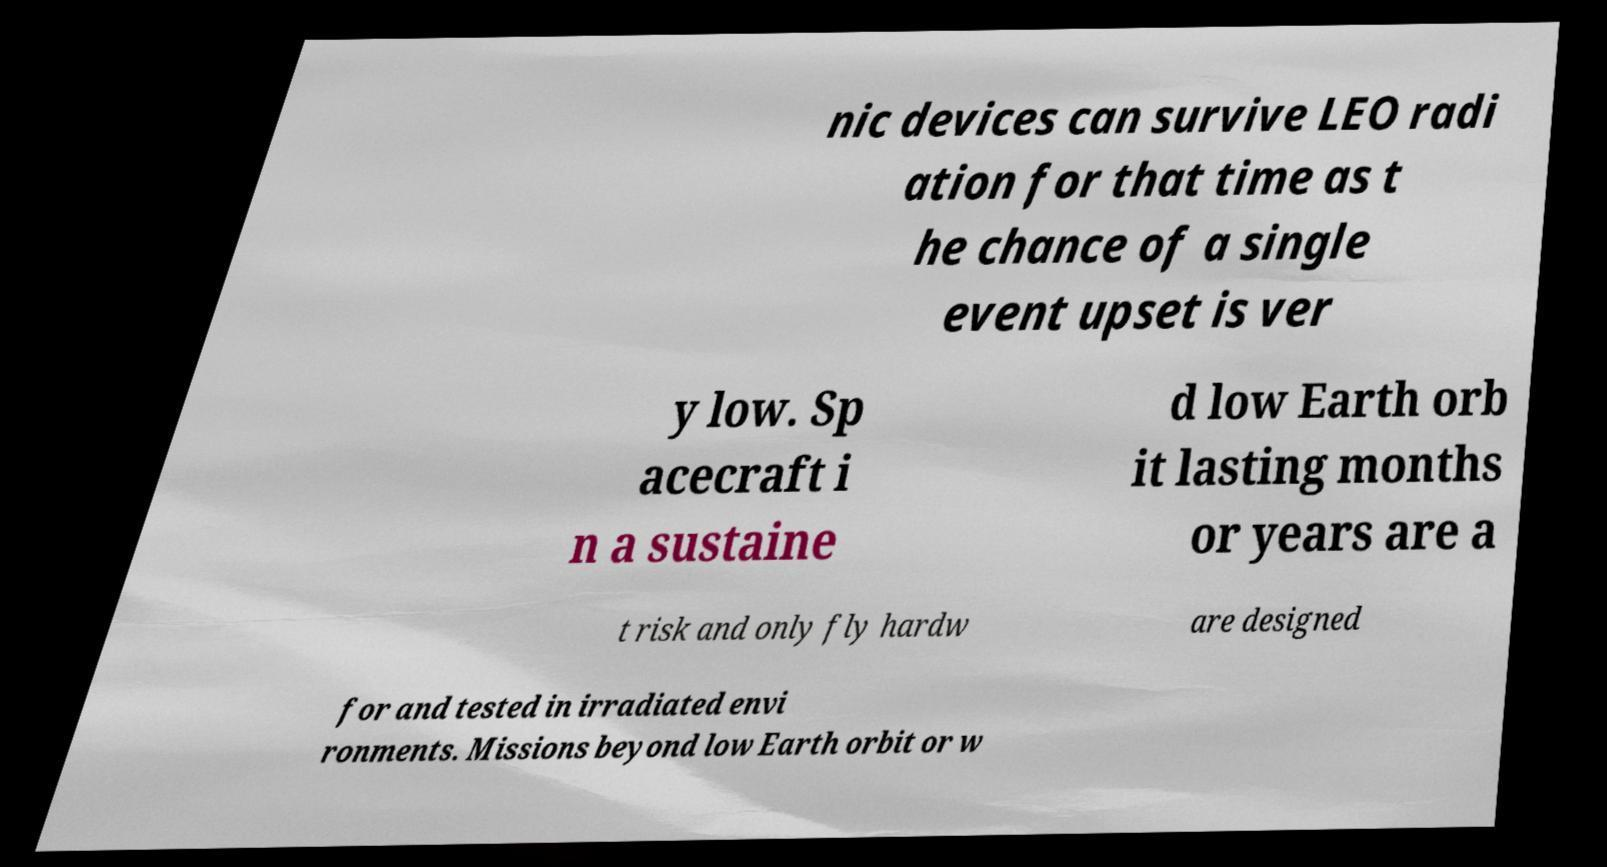Please identify and transcribe the text found in this image. nic devices can survive LEO radi ation for that time as t he chance of a single event upset is ver y low. Sp acecraft i n a sustaine d low Earth orb it lasting months or years are a t risk and only fly hardw are designed for and tested in irradiated envi ronments. Missions beyond low Earth orbit or w 